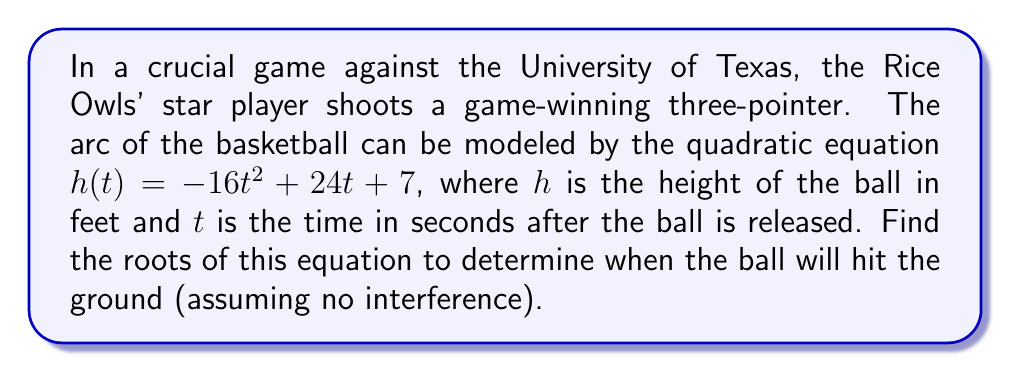Teach me how to tackle this problem. To find the roots of the quadratic equation, we need to solve $h(t) = 0$. Let's follow these steps:

1) Set the equation equal to zero:
   $-16t^2 + 24t + 7 = 0$

2) This is in the standard form of a quadratic equation: $at^2 + bt + c = 0$
   Where $a = -16$, $b = 24$, and $c = 7$

3) We can solve this using the quadratic formula: $t = \frac{-b \pm \sqrt{b^2 - 4ac}}{2a}$

4) Let's substitute our values:
   $t = \frac{-24 \pm \sqrt{24^2 - 4(-16)(7)}}{2(-16)}$

5) Simplify under the square root:
   $t = \frac{-24 \pm \sqrt{576 + 448}}{-32} = \frac{-24 \pm \sqrt{1024}}{-32}$

6) Simplify the square root:
   $t = \frac{-24 \pm 32}{-32}$

7) This gives us two solutions:
   $t = \frac{-24 + 32}{-32} = \frac{8}{-32} = -0.25$
   $t = \frac{-24 - 32}{-32} = \frac{-56}{-32} = 1.75$

The negative solution (-0.25) doesn't make sense in the context of the problem, as time cannot be negative after the ball is released. Therefore, the ball will hit the ground after 1.75 seconds.
Answer: The roots of the equation are $t = -0.25$ and $t = 1.75$. In the context of the basketball shot, the ball will hit the ground after 1.75 seconds. 